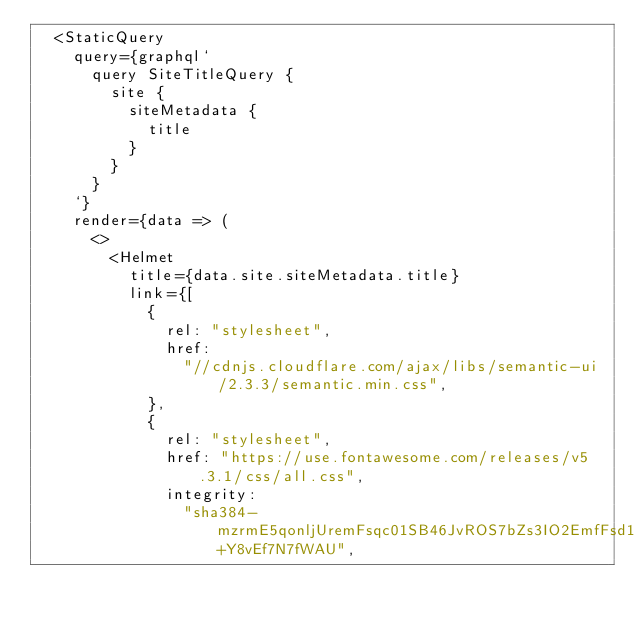Convert code to text. <code><loc_0><loc_0><loc_500><loc_500><_JavaScript_>  <StaticQuery
    query={graphql`
      query SiteTitleQuery {
        site {
          siteMetadata {
            title
          }
        }
      }
    `}
    render={data => (
      <>
        <Helmet
          title={data.site.siteMetadata.title}
          link={[
            {
              rel: "stylesheet",
              href:
                "//cdnjs.cloudflare.com/ajax/libs/semantic-ui/2.3.3/semantic.min.css",
            },
            {
              rel: "stylesheet",
              href: "https://use.fontawesome.com/releases/v5.3.1/css/all.css",
              integrity:
                "sha384-mzrmE5qonljUremFsqc01SB46JvROS7bZs3IO2EmfFsd15uHvIt+Y8vEf7N7fWAU",</code> 